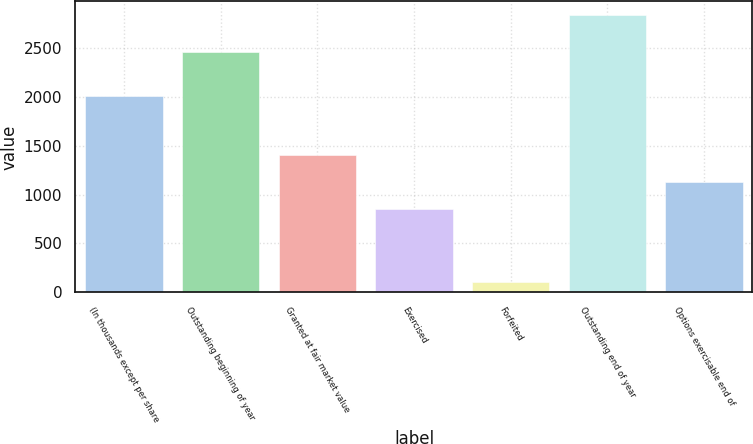Convert chart to OTSL. <chart><loc_0><loc_0><loc_500><loc_500><bar_chart><fcel>(In thousands except per share<fcel>Outstanding beginning of year<fcel>Granted at fair market value<fcel>Exercised<fcel>Forfeited<fcel>Outstanding end of year<fcel>Options exercisable end of<nl><fcel>2009<fcel>2456<fcel>1398.8<fcel>853<fcel>102<fcel>2831<fcel>1125.9<nl></chart> 